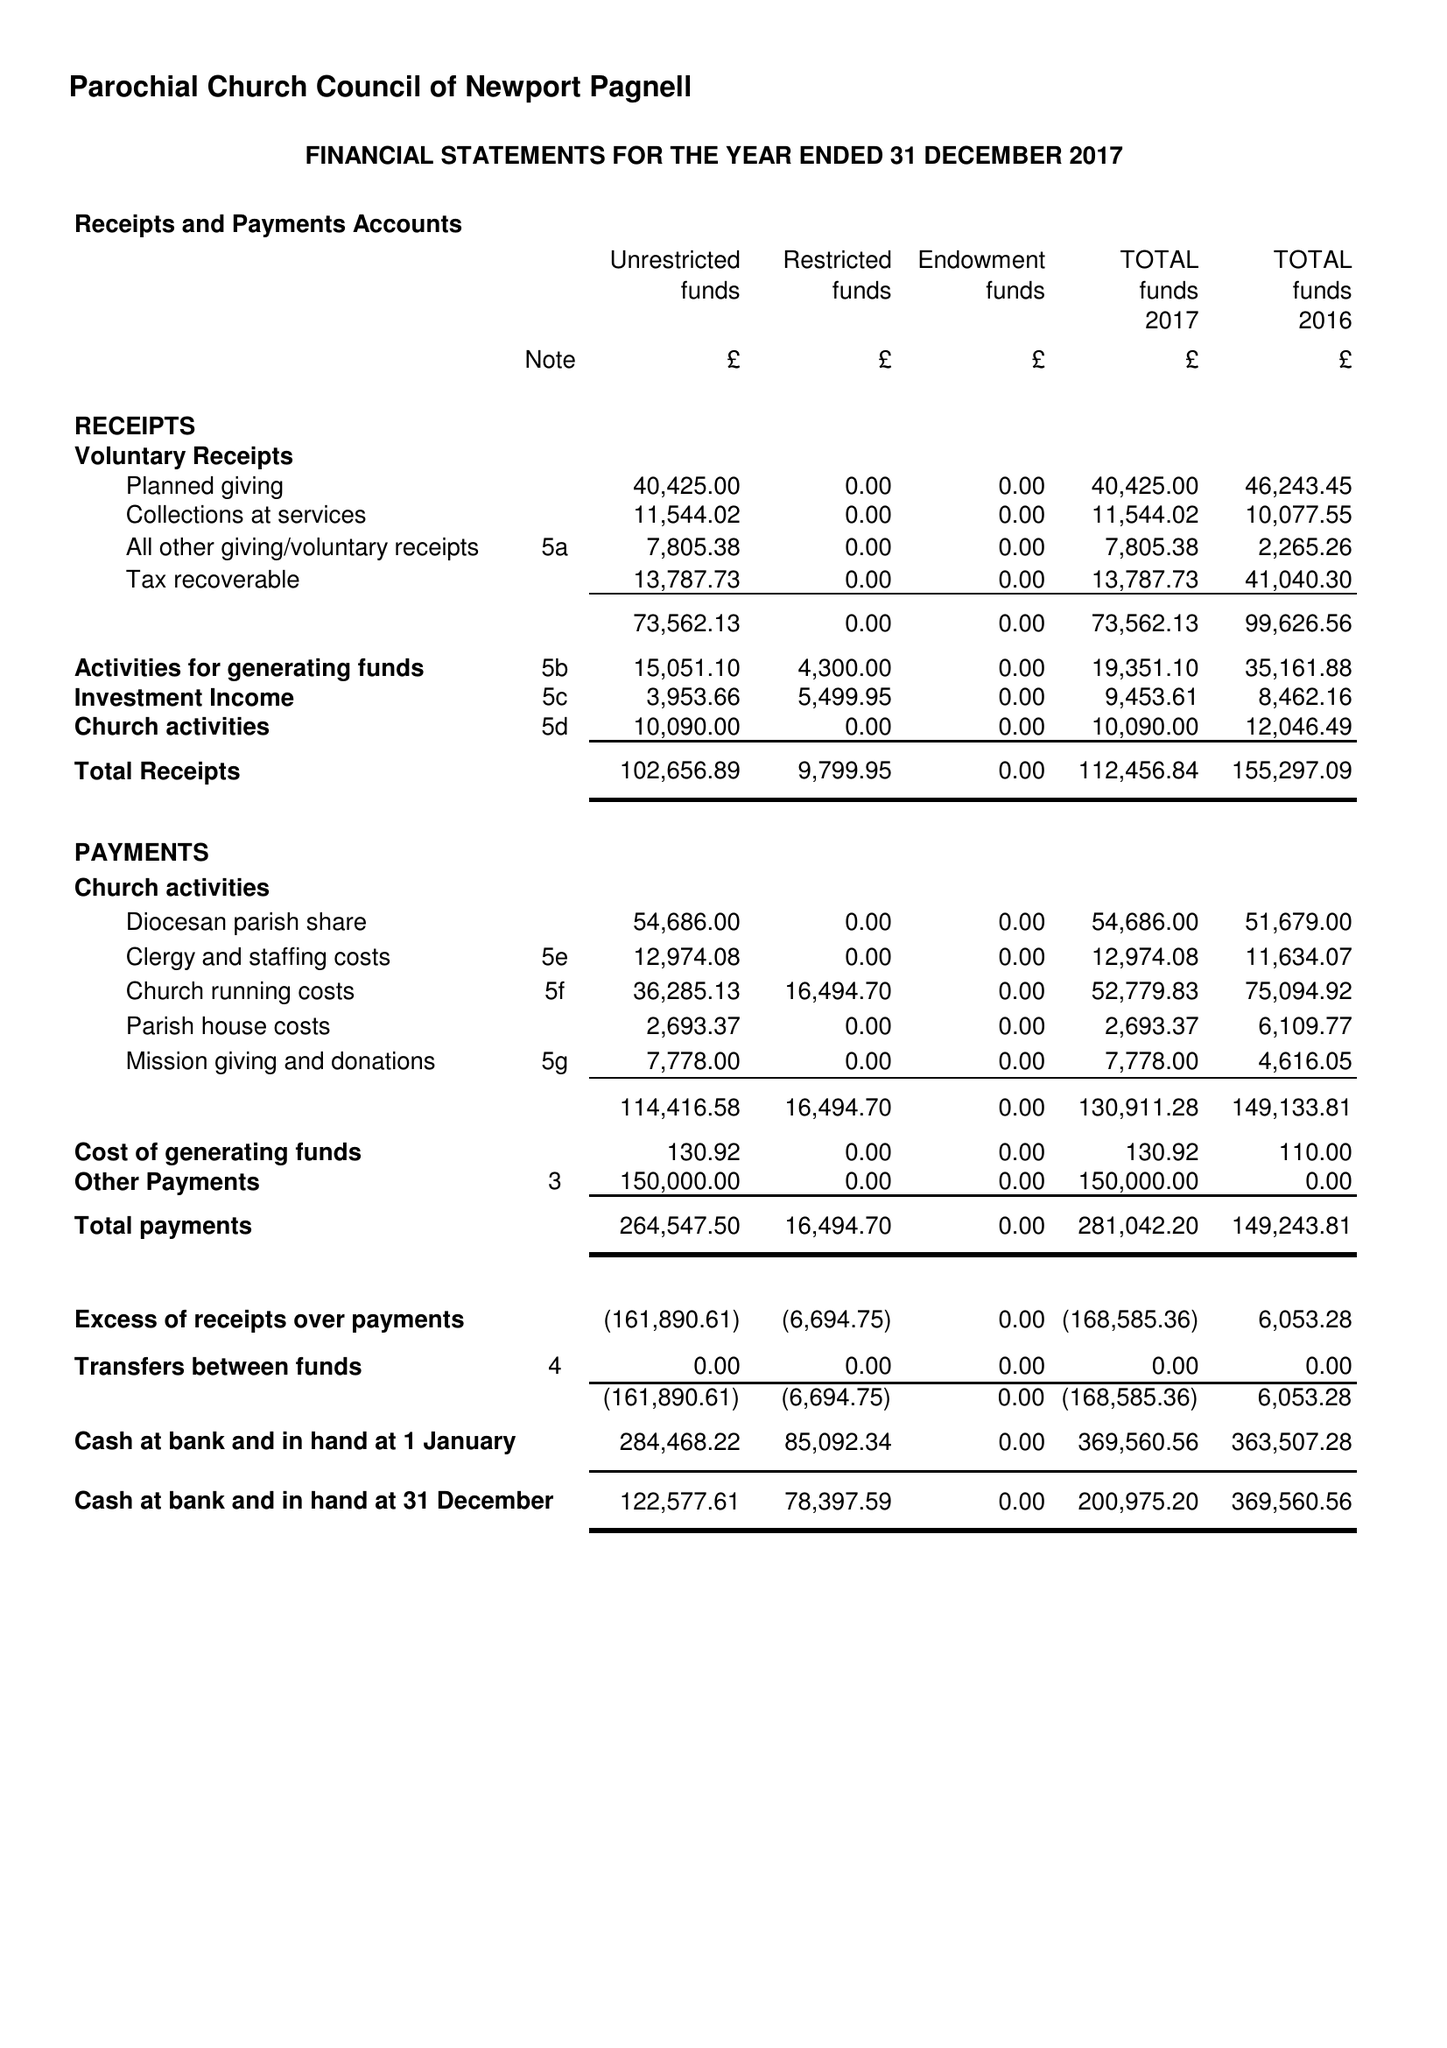What is the value for the charity_name?
Answer the question using a single word or phrase. The Parochial Church Council Of The Ecclesiastical Parish Of St Peter and St Paul With St Luke, Newport Pagnell 